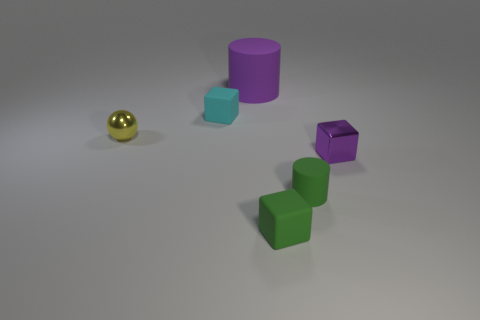What material is the other object that is the same shape as the large rubber thing?
Make the answer very short. Rubber. How many purple metallic objects are behind the cylinder that is behind the purple shiny block?
Provide a short and direct response. 0. There is a rubber block that is behind the shiny object on the right side of the large purple object that is right of the cyan object; what is its size?
Your response must be concise. Small. What color is the rubber block that is in front of the purple thing to the right of the large cylinder?
Provide a short and direct response. Green. What number of other things are there of the same material as the small yellow ball
Keep it short and to the point. 1. How many other objects are the same color as the big thing?
Ensure brevity in your answer.  1. The tiny object that is on the left side of the tiny cube that is behind the tiny shiny block is made of what material?
Your answer should be compact. Metal. Is there a small metallic cylinder?
Your answer should be compact. No. What is the size of the matte cylinder right of the cylinder that is behind the tiny cyan thing?
Ensure brevity in your answer.  Small. Are there more shiny things that are to the right of the small matte cylinder than objects that are in front of the shiny ball?
Your response must be concise. No. 